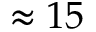Convert formula to latex. <formula><loc_0><loc_0><loc_500><loc_500>\approx 1 5</formula> 